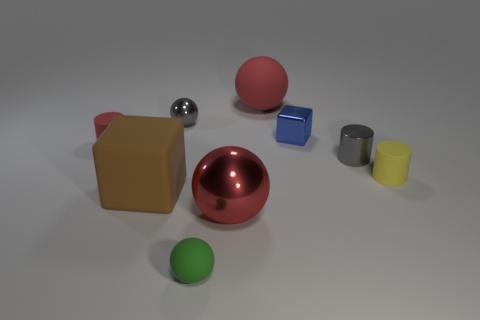Subtract all yellow rubber cylinders. How many cylinders are left? 2 Subtract all green balls. How many balls are left? 3 Subtract all blocks. How many objects are left? 7 Subtract 2 cylinders. How many cylinders are left? 1 Subtract all blue cylinders. Subtract all red cubes. How many cylinders are left? 3 Subtract all yellow cubes. How many green balls are left? 1 Subtract all tiny objects. Subtract all cyan metal blocks. How many objects are left? 3 Add 1 metal spheres. How many metal spheres are left? 3 Add 3 large red metallic objects. How many large red metallic objects exist? 4 Add 1 blue metal cylinders. How many objects exist? 10 